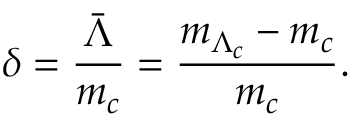<formula> <loc_0><loc_0><loc_500><loc_500>\delta = { \frac { \bar { \Lambda } } { m _ { c } } } = { \frac { m _ { \Lambda _ { c } } - m _ { c } } { m _ { c } } } .</formula> 